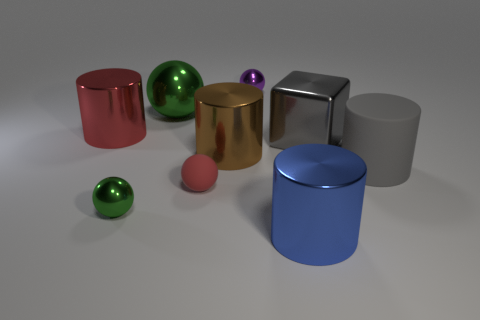Add 1 rubber things. How many objects exist? 10 Subtract all balls. How many objects are left? 5 Add 8 gray shiny cylinders. How many gray shiny cylinders exist? 8 Subtract 1 gray cylinders. How many objects are left? 8 Subtract all shiny cubes. Subtract all tiny purple metallic objects. How many objects are left? 7 Add 2 large blue shiny cylinders. How many large blue shiny cylinders are left? 3 